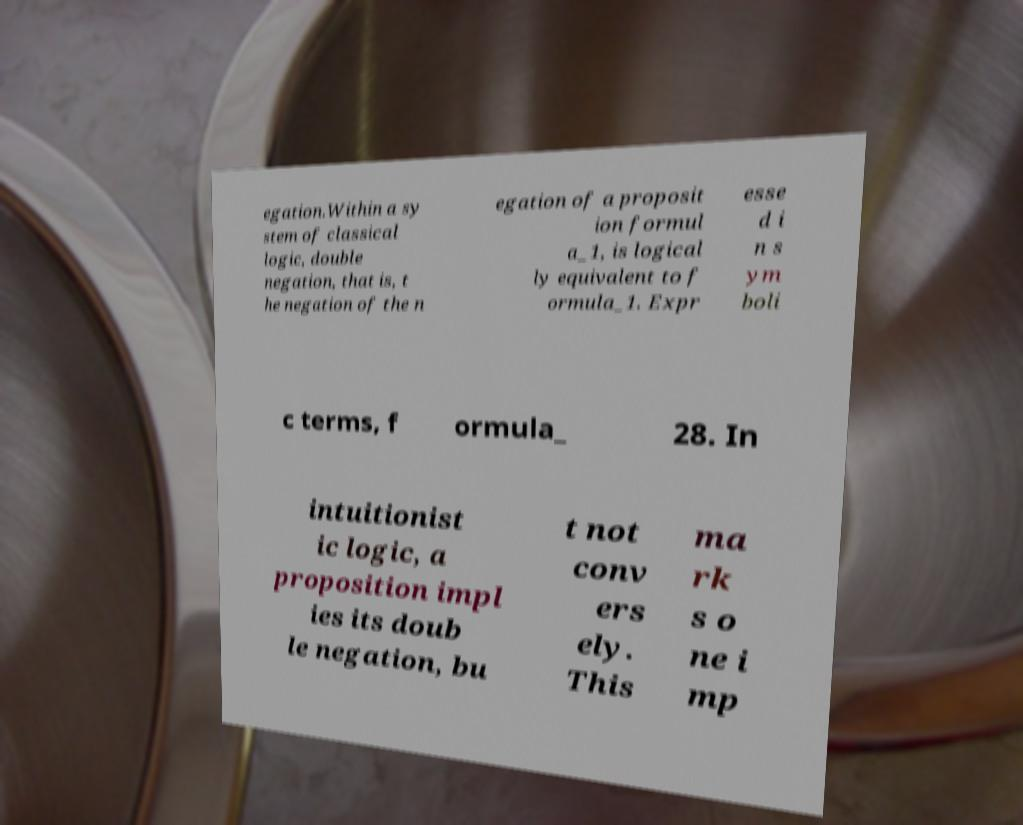Can you read and provide the text displayed in the image?This photo seems to have some interesting text. Can you extract and type it out for me? egation.Within a sy stem of classical logic, double negation, that is, t he negation of the n egation of a proposit ion formul a_1, is logical ly equivalent to f ormula_1. Expr esse d i n s ym boli c terms, f ormula_ 28. In intuitionist ic logic, a proposition impl ies its doub le negation, bu t not conv ers ely. This ma rk s o ne i mp 